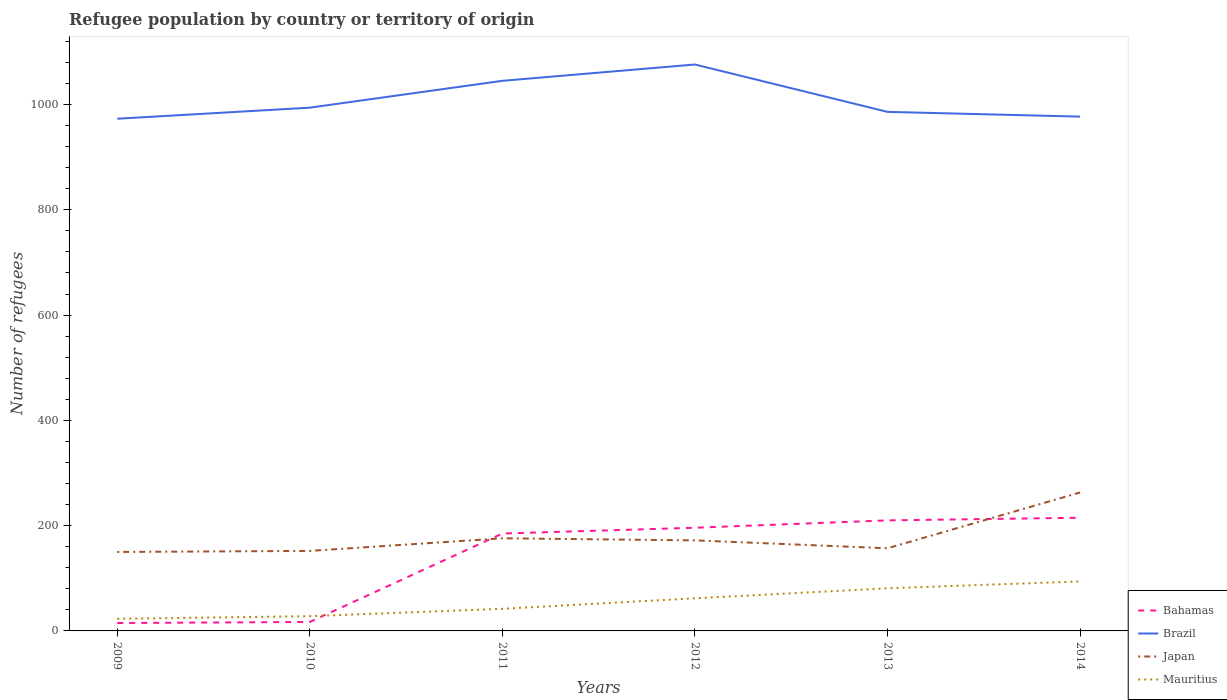Is the number of lines equal to the number of legend labels?
Offer a terse response. Yes. What is the difference between the highest and the second highest number of refugees in Japan?
Provide a succinct answer. 113. What is the difference between the highest and the lowest number of refugees in Japan?
Your response must be concise. 1. How many lines are there?
Provide a short and direct response. 4. How many years are there in the graph?
Your response must be concise. 6. Does the graph contain any zero values?
Make the answer very short. No. What is the title of the graph?
Keep it short and to the point. Refugee population by country or territory of origin. What is the label or title of the X-axis?
Your answer should be compact. Years. What is the label or title of the Y-axis?
Provide a succinct answer. Number of refugees. What is the Number of refugees of Bahamas in 2009?
Keep it short and to the point. 15. What is the Number of refugees in Brazil in 2009?
Your answer should be compact. 973. What is the Number of refugees of Japan in 2009?
Your response must be concise. 150. What is the Number of refugees in Mauritius in 2009?
Make the answer very short. 23. What is the Number of refugees in Bahamas in 2010?
Your answer should be compact. 17. What is the Number of refugees of Brazil in 2010?
Provide a succinct answer. 994. What is the Number of refugees in Japan in 2010?
Offer a very short reply. 152. What is the Number of refugees of Bahamas in 2011?
Your answer should be compact. 185. What is the Number of refugees in Brazil in 2011?
Give a very brief answer. 1045. What is the Number of refugees in Japan in 2011?
Your response must be concise. 176. What is the Number of refugees of Bahamas in 2012?
Give a very brief answer. 196. What is the Number of refugees of Brazil in 2012?
Your answer should be compact. 1076. What is the Number of refugees in Japan in 2012?
Ensure brevity in your answer.  172. What is the Number of refugees in Bahamas in 2013?
Offer a terse response. 210. What is the Number of refugees of Brazil in 2013?
Provide a short and direct response. 986. What is the Number of refugees in Japan in 2013?
Your answer should be very brief. 157. What is the Number of refugees in Mauritius in 2013?
Your response must be concise. 81. What is the Number of refugees of Bahamas in 2014?
Provide a short and direct response. 215. What is the Number of refugees of Brazil in 2014?
Provide a succinct answer. 977. What is the Number of refugees in Japan in 2014?
Ensure brevity in your answer.  263. What is the Number of refugees in Mauritius in 2014?
Provide a short and direct response. 94. Across all years, what is the maximum Number of refugees of Bahamas?
Keep it short and to the point. 215. Across all years, what is the maximum Number of refugees in Brazil?
Keep it short and to the point. 1076. Across all years, what is the maximum Number of refugees of Japan?
Your response must be concise. 263. Across all years, what is the maximum Number of refugees in Mauritius?
Provide a short and direct response. 94. Across all years, what is the minimum Number of refugees of Brazil?
Your answer should be compact. 973. Across all years, what is the minimum Number of refugees in Japan?
Provide a short and direct response. 150. Across all years, what is the minimum Number of refugees of Mauritius?
Keep it short and to the point. 23. What is the total Number of refugees of Bahamas in the graph?
Provide a succinct answer. 838. What is the total Number of refugees of Brazil in the graph?
Your answer should be compact. 6051. What is the total Number of refugees in Japan in the graph?
Ensure brevity in your answer.  1070. What is the total Number of refugees in Mauritius in the graph?
Provide a short and direct response. 330. What is the difference between the Number of refugees of Brazil in 2009 and that in 2010?
Offer a terse response. -21. What is the difference between the Number of refugees of Mauritius in 2009 and that in 2010?
Make the answer very short. -5. What is the difference between the Number of refugees of Bahamas in 2009 and that in 2011?
Provide a succinct answer. -170. What is the difference between the Number of refugees in Brazil in 2009 and that in 2011?
Your answer should be very brief. -72. What is the difference between the Number of refugees in Bahamas in 2009 and that in 2012?
Your response must be concise. -181. What is the difference between the Number of refugees of Brazil in 2009 and that in 2012?
Your response must be concise. -103. What is the difference between the Number of refugees of Japan in 2009 and that in 2012?
Your answer should be very brief. -22. What is the difference between the Number of refugees in Mauritius in 2009 and that in 2012?
Provide a succinct answer. -39. What is the difference between the Number of refugees in Bahamas in 2009 and that in 2013?
Offer a terse response. -195. What is the difference between the Number of refugees of Brazil in 2009 and that in 2013?
Offer a terse response. -13. What is the difference between the Number of refugees of Japan in 2009 and that in 2013?
Offer a terse response. -7. What is the difference between the Number of refugees of Mauritius in 2009 and that in 2013?
Provide a succinct answer. -58. What is the difference between the Number of refugees of Bahamas in 2009 and that in 2014?
Offer a very short reply. -200. What is the difference between the Number of refugees of Brazil in 2009 and that in 2014?
Provide a short and direct response. -4. What is the difference between the Number of refugees of Japan in 2009 and that in 2014?
Make the answer very short. -113. What is the difference between the Number of refugees in Mauritius in 2009 and that in 2014?
Ensure brevity in your answer.  -71. What is the difference between the Number of refugees in Bahamas in 2010 and that in 2011?
Make the answer very short. -168. What is the difference between the Number of refugees of Brazil in 2010 and that in 2011?
Offer a very short reply. -51. What is the difference between the Number of refugees of Bahamas in 2010 and that in 2012?
Your response must be concise. -179. What is the difference between the Number of refugees of Brazil in 2010 and that in 2012?
Your answer should be very brief. -82. What is the difference between the Number of refugees of Japan in 2010 and that in 2012?
Provide a succinct answer. -20. What is the difference between the Number of refugees in Mauritius in 2010 and that in 2012?
Give a very brief answer. -34. What is the difference between the Number of refugees in Bahamas in 2010 and that in 2013?
Your response must be concise. -193. What is the difference between the Number of refugees in Mauritius in 2010 and that in 2013?
Make the answer very short. -53. What is the difference between the Number of refugees in Bahamas in 2010 and that in 2014?
Offer a terse response. -198. What is the difference between the Number of refugees of Brazil in 2010 and that in 2014?
Provide a succinct answer. 17. What is the difference between the Number of refugees in Japan in 2010 and that in 2014?
Offer a terse response. -111. What is the difference between the Number of refugees of Mauritius in 2010 and that in 2014?
Offer a terse response. -66. What is the difference between the Number of refugees of Bahamas in 2011 and that in 2012?
Ensure brevity in your answer.  -11. What is the difference between the Number of refugees of Brazil in 2011 and that in 2012?
Ensure brevity in your answer.  -31. What is the difference between the Number of refugees of Brazil in 2011 and that in 2013?
Provide a short and direct response. 59. What is the difference between the Number of refugees in Japan in 2011 and that in 2013?
Your answer should be compact. 19. What is the difference between the Number of refugees in Mauritius in 2011 and that in 2013?
Keep it short and to the point. -39. What is the difference between the Number of refugees of Bahamas in 2011 and that in 2014?
Your answer should be compact. -30. What is the difference between the Number of refugees of Japan in 2011 and that in 2014?
Keep it short and to the point. -87. What is the difference between the Number of refugees in Mauritius in 2011 and that in 2014?
Offer a terse response. -52. What is the difference between the Number of refugees in Japan in 2012 and that in 2013?
Provide a short and direct response. 15. What is the difference between the Number of refugees in Mauritius in 2012 and that in 2013?
Your response must be concise. -19. What is the difference between the Number of refugees of Brazil in 2012 and that in 2014?
Offer a very short reply. 99. What is the difference between the Number of refugees in Japan in 2012 and that in 2014?
Offer a very short reply. -91. What is the difference between the Number of refugees in Mauritius in 2012 and that in 2014?
Provide a short and direct response. -32. What is the difference between the Number of refugees in Bahamas in 2013 and that in 2014?
Ensure brevity in your answer.  -5. What is the difference between the Number of refugees in Brazil in 2013 and that in 2014?
Keep it short and to the point. 9. What is the difference between the Number of refugees in Japan in 2013 and that in 2014?
Make the answer very short. -106. What is the difference between the Number of refugees in Bahamas in 2009 and the Number of refugees in Brazil in 2010?
Your answer should be very brief. -979. What is the difference between the Number of refugees in Bahamas in 2009 and the Number of refugees in Japan in 2010?
Provide a succinct answer. -137. What is the difference between the Number of refugees of Bahamas in 2009 and the Number of refugees of Mauritius in 2010?
Offer a terse response. -13. What is the difference between the Number of refugees of Brazil in 2009 and the Number of refugees of Japan in 2010?
Your response must be concise. 821. What is the difference between the Number of refugees in Brazil in 2009 and the Number of refugees in Mauritius in 2010?
Ensure brevity in your answer.  945. What is the difference between the Number of refugees of Japan in 2009 and the Number of refugees of Mauritius in 2010?
Your response must be concise. 122. What is the difference between the Number of refugees in Bahamas in 2009 and the Number of refugees in Brazil in 2011?
Offer a terse response. -1030. What is the difference between the Number of refugees of Bahamas in 2009 and the Number of refugees of Japan in 2011?
Provide a succinct answer. -161. What is the difference between the Number of refugees of Bahamas in 2009 and the Number of refugees of Mauritius in 2011?
Your response must be concise. -27. What is the difference between the Number of refugees of Brazil in 2009 and the Number of refugees of Japan in 2011?
Offer a very short reply. 797. What is the difference between the Number of refugees in Brazil in 2009 and the Number of refugees in Mauritius in 2011?
Make the answer very short. 931. What is the difference between the Number of refugees of Japan in 2009 and the Number of refugees of Mauritius in 2011?
Provide a succinct answer. 108. What is the difference between the Number of refugees of Bahamas in 2009 and the Number of refugees of Brazil in 2012?
Your response must be concise. -1061. What is the difference between the Number of refugees in Bahamas in 2009 and the Number of refugees in Japan in 2012?
Offer a terse response. -157. What is the difference between the Number of refugees of Bahamas in 2009 and the Number of refugees of Mauritius in 2012?
Ensure brevity in your answer.  -47. What is the difference between the Number of refugees in Brazil in 2009 and the Number of refugees in Japan in 2012?
Ensure brevity in your answer.  801. What is the difference between the Number of refugees of Brazil in 2009 and the Number of refugees of Mauritius in 2012?
Offer a terse response. 911. What is the difference between the Number of refugees of Bahamas in 2009 and the Number of refugees of Brazil in 2013?
Your answer should be very brief. -971. What is the difference between the Number of refugees of Bahamas in 2009 and the Number of refugees of Japan in 2013?
Your response must be concise. -142. What is the difference between the Number of refugees in Bahamas in 2009 and the Number of refugees in Mauritius in 2013?
Your answer should be very brief. -66. What is the difference between the Number of refugees of Brazil in 2009 and the Number of refugees of Japan in 2013?
Offer a terse response. 816. What is the difference between the Number of refugees of Brazil in 2009 and the Number of refugees of Mauritius in 2013?
Offer a terse response. 892. What is the difference between the Number of refugees of Bahamas in 2009 and the Number of refugees of Brazil in 2014?
Your answer should be very brief. -962. What is the difference between the Number of refugees in Bahamas in 2009 and the Number of refugees in Japan in 2014?
Ensure brevity in your answer.  -248. What is the difference between the Number of refugees of Bahamas in 2009 and the Number of refugees of Mauritius in 2014?
Your answer should be compact. -79. What is the difference between the Number of refugees in Brazil in 2009 and the Number of refugees in Japan in 2014?
Your response must be concise. 710. What is the difference between the Number of refugees in Brazil in 2009 and the Number of refugees in Mauritius in 2014?
Your answer should be compact. 879. What is the difference between the Number of refugees in Bahamas in 2010 and the Number of refugees in Brazil in 2011?
Provide a succinct answer. -1028. What is the difference between the Number of refugees in Bahamas in 2010 and the Number of refugees in Japan in 2011?
Give a very brief answer. -159. What is the difference between the Number of refugees in Brazil in 2010 and the Number of refugees in Japan in 2011?
Make the answer very short. 818. What is the difference between the Number of refugees in Brazil in 2010 and the Number of refugees in Mauritius in 2011?
Give a very brief answer. 952. What is the difference between the Number of refugees of Japan in 2010 and the Number of refugees of Mauritius in 2011?
Provide a succinct answer. 110. What is the difference between the Number of refugees in Bahamas in 2010 and the Number of refugees in Brazil in 2012?
Make the answer very short. -1059. What is the difference between the Number of refugees in Bahamas in 2010 and the Number of refugees in Japan in 2012?
Keep it short and to the point. -155. What is the difference between the Number of refugees in Bahamas in 2010 and the Number of refugees in Mauritius in 2012?
Give a very brief answer. -45. What is the difference between the Number of refugees in Brazil in 2010 and the Number of refugees in Japan in 2012?
Your answer should be compact. 822. What is the difference between the Number of refugees of Brazil in 2010 and the Number of refugees of Mauritius in 2012?
Provide a short and direct response. 932. What is the difference between the Number of refugees in Japan in 2010 and the Number of refugees in Mauritius in 2012?
Your response must be concise. 90. What is the difference between the Number of refugees in Bahamas in 2010 and the Number of refugees in Brazil in 2013?
Your response must be concise. -969. What is the difference between the Number of refugees of Bahamas in 2010 and the Number of refugees of Japan in 2013?
Your answer should be compact. -140. What is the difference between the Number of refugees in Bahamas in 2010 and the Number of refugees in Mauritius in 2013?
Provide a succinct answer. -64. What is the difference between the Number of refugees of Brazil in 2010 and the Number of refugees of Japan in 2013?
Offer a terse response. 837. What is the difference between the Number of refugees in Brazil in 2010 and the Number of refugees in Mauritius in 2013?
Provide a short and direct response. 913. What is the difference between the Number of refugees in Japan in 2010 and the Number of refugees in Mauritius in 2013?
Offer a terse response. 71. What is the difference between the Number of refugees of Bahamas in 2010 and the Number of refugees of Brazil in 2014?
Ensure brevity in your answer.  -960. What is the difference between the Number of refugees of Bahamas in 2010 and the Number of refugees of Japan in 2014?
Your answer should be very brief. -246. What is the difference between the Number of refugees of Bahamas in 2010 and the Number of refugees of Mauritius in 2014?
Offer a very short reply. -77. What is the difference between the Number of refugees in Brazil in 2010 and the Number of refugees in Japan in 2014?
Offer a very short reply. 731. What is the difference between the Number of refugees in Brazil in 2010 and the Number of refugees in Mauritius in 2014?
Offer a terse response. 900. What is the difference between the Number of refugees of Bahamas in 2011 and the Number of refugees of Brazil in 2012?
Provide a succinct answer. -891. What is the difference between the Number of refugees of Bahamas in 2011 and the Number of refugees of Japan in 2012?
Provide a short and direct response. 13. What is the difference between the Number of refugees of Bahamas in 2011 and the Number of refugees of Mauritius in 2012?
Make the answer very short. 123. What is the difference between the Number of refugees of Brazil in 2011 and the Number of refugees of Japan in 2012?
Provide a short and direct response. 873. What is the difference between the Number of refugees in Brazil in 2011 and the Number of refugees in Mauritius in 2012?
Make the answer very short. 983. What is the difference between the Number of refugees in Japan in 2011 and the Number of refugees in Mauritius in 2012?
Offer a very short reply. 114. What is the difference between the Number of refugees in Bahamas in 2011 and the Number of refugees in Brazil in 2013?
Provide a succinct answer. -801. What is the difference between the Number of refugees in Bahamas in 2011 and the Number of refugees in Mauritius in 2013?
Your answer should be very brief. 104. What is the difference between the Number of refugees in Brazil in 2011 and the Number of refugees in Japan in 2013?
Provide a succinct answer. 888. What is the difference between the Number of refugees in Brazil in 2011 and the Number of refugees in Mauritius in 2013?
Offer a terse response. 964. What is the difference between the Number of refugees in Japan in 2011 and the Number of refugees in Mauritius in 2013?
Your answer should be compact. 95. What is the difference between the Number of refugees of Bahamas in 2011 and the Number of refugees of Brazil in 2014?
Make the answer very short. -792. What is the difference between the Number of refugees of Bahamas in 2011 and the Number of refugees of Japan in 2014?
Provide a short and direct response. -78. What is the difference between the Number of refugees in Bahamas in 2011 and the Number of refugees in Mauritius in 2014?
Your answer should be compact. 91. What is the difference between the Number of refugees of Brazil in 2011 and the Number of refugees of Japan in 2014?
Provide a succinct answer. 782. What is the difference between the Number of refugees in Brazil in 2011 and the Number of refugees in Mauritius in 2014?
Keep it short and to the point. 951. What is the difference between the Number of refugees of Japan in 2011 and the Number of refugees of Mauritius in 2014?
Provide a short and direct response. 82. What is the difference between the Number of refugees in Bahamas in 2012 and the Number of refugees in Brazil in 2013?
Offer a terse response. -790. What is the difference between the Number of refugees of Bahamas in 2012 and the Number of refugees of Japan in 2013?
Your response must be concise. 39. What is the difference between the Number of refugees in Bahamas in 2012 and the Number of refugees in Mauritius in 2013?
Provide a short and direct response. 115. What is the difference between the Number of refugees in Brazil in 2012 and the Number of refugees in Japan in 2013?
Provide a short and direct response. 919. What is the difference between the Number of refugees in Brazil in 2012 and the Number of refugees in Mauritius in 2013?
Offer a terse response. 995. What is the difference between the Number of refugees in Japan in 2012 and the Number of refugees in Mauritius in 2013?
Make the answer very short. 91. What is the difference between the Number of refugees of Bahamas in 2012 and the Number of refugees of Brazil in 2014?
Make the answer very short. -781. What is the difference between the Number of refugees in Bahamas in 2012 and the Number of refugees in Japan in 2014?
Ensure brevity in your answer.  -67. What is the difference between the Number of refugees of Bahamas in 2012 and the Number of refugees of Mauritius in 2014?
Offer a terse response. 102. What is the difference between the Number of refugees in Brazil in 2012 and the Number of refugees in Japan in 2014?
Make the answer very short. 813. What is the difference between the Number of refugees in Brazil in 2012 and the Number of refugees in Mauritius in 2014?
Your response must be concise. 982. What is the difference between the Number of refugees in Bahamas in 2013 and the Number of refugees in Brazil in 2014?
Your answer should be compact. -767. What is the difference between the Number of refugees in Bahamas in 2013 and the Number of refugees in Japan in 2014?
Offer a very short reply. -53. What is the difference between the Number of refugees in Bahamas in 2013 and the Number of refugees in Mauritius in 2014?
Your answer should be very brief. 116. What is the difference between the Number of refugees of Brazil in 2013 and the Number of refugees of Japan in 2014?
Your response must be concise. 723. What is the difference between the Number of refugees in Brazil in 2013 and the Number of refugees in Mauritius in 2014?
Your answer should be very brief. 892. What is the difference between the Number of refugees of Japan in 2013 and the Number of refugees of Mauritius in 2014?
Offer a very short reply. 63. What is the average Number of refugees of Bahamas per year?
Make the answer very short. 139.67. What is the average Number of refugees in Brazil per year?
Your response must be concise. 1008.5. What is the average Number of refugees in Japan per year?
Keep it short and to the point. 178.33. What is the average Number of refugees in Mauritius per year?
Provide a short and direct response. 55. In the year 2009, what is the difference between the Number of refugees in Bahamas and Number of refugees in Brazil?
Your answer should be very brief. -958. In the year 2009, what is the difference between the Number of refugees of Bahamas and Number of refugees of Japan?
Keep it short and to the point. -135. In the year 2009, what is the difference between the Number of refugees of Bahamas and Number of refugees of Mauritius?
Offer a very short reply. -8. In the year 2009, what is the difference between the Number of refugees of Brazil and Number of refugees of Japan?
Your answer should be very brief. 823. In the year 2009, what is the difference between the Number of refugees of Brazil and Number of refugees of Mauritius?
Your answer should be very brief. 950. In the year 2009, what is the difference between the Number of refugees in Japan and Number of refugees in Mauritius?
Your answer should be very brief. 127. In the year 2010, what is the difference between the Number of refugees of Bahamas and Number of refugees of Brazil?
Your answer should be very brief. -977. In the year 2010, what is the difference between the Number of refugees in Bahamas and Number of refugees in Japan?
Ensure brevity in your answer.  -135. In the year 2010, what is the difference between the Number of refugees in Brazil and Number of refugees in Japan?
Keep it short and to the point. 842. In the year 2010, what is the difference between the Number of refugees in Brazil and Number of refugees in Mauritius?
Offer a terse response. 966. In the year 2010, what is the difference between the Number of refugees in Japan and Number of refugees in Mauritius?
Your response must be concise. 124. In the year 2011, what is the difference between the Number of refugees of Bahamas and Number of refugees of Brazil?
Give a very brief answer. -860. In the year 2011, what is the difference between the Number of refugees in Bahamas and Number of refugees in Mauritius?
Provide a succinct answer. 143. In the year 2011, what is the difference between the Number of refugees in Brazil and Number of refugees in Japan?
Your response must be concise. 869. In the year 2011, what is the difference between the Number of refugees in Brazil and Number of refugees in Mauritius?
Give a very brief answer. 1003. In the year 2011, what is the difference between the Number of refugees of Japan and Number of refugees of Mauritius?
Give a very brief answer. 134. In the year 2012, what is the difference between the Number of refugees of Bahamas and Number of refugees of Brazil?
Offer a terse response. -880. In the year 2012, what is the difference between the Number of refugees in Bahamas and Number of refugees in Mauritius?
Your response must be concise. 134. In the year 2012, what is the difference between the Number of refugees in Brazil and Number of refugees in Japan?
Your answer should be very brief. 904. In the year 2012, what is the difference between the Number of refugees in Brazil and Number of refugees in Mauritius?
Provide a succinct answer. 1014. In the year 2012, what is the difference between the Number of refugees in Japan and Number of refugees in Mauritius?
Ensure brevity in your answer.  110. In the year 2013, what is the difference between the Number of refugees of Bahamas and Number of refugees of Brazil?
Provide a short and direct response. -776. In the year 2013, what is the difference between the Number of refugees of Bahamas and Number of refugees of Mauritius?
Make the answer very short. 129. In the year 2013, what is the difference between the Number of refugees in Brazil and Number of refugees in Japan?
Your answer should be compact. 829. In the year 2013, what is the difference between the Number of refugees of Brazil and Number of refugees of Mauritius?
Make the answer very short. 905. In the year 2013, what is the difference between the Number of refugees in Japan and Number of refugees in Mauritius?
Offer a very short reply. 76. In the year 2014, what is the difference between the Number of refugees of Bahamas and Number of refugees of Brazil?
Offer a terse response. -762. In the year 2014, what is the difference between the Number of refugees of Bahamas and Number of refugees of Japan?
Your response must be concise. -48. In the year 2014, what is the difference between the Number of refugees in Bahamas and Number of refugees in Mauritius?
Make the answer very short. 121. In the year 2014, what is the difference between the Number of refugees in Brazil and Number of refugees in Japan?
Provide a succinct answer. 714. In the year 2014, what is the difference between the Number of refugees of Brazil and Number of refugees of Mauritius?
Your answer should be very brief. 883. In the year 2014, what is the difference between the Number of refugees of Japan and Number of refugees of Mauritius?
Your answer should be very brief. 169. What is the ratio of the Number of refugees in Bahamas in 2009 to that in 2010?
Give a very brief answer. 0.88. What is the ratio of the Number of refugees in Brazil in 2009 to that in 2010?
Your response must be concise. 0.98. What is the ratio of the Number of refugees in Japan in 2009 to that in 2010?
Make the answer very short. 0.99. What is the ratio of the Number of refugees in Mauritius in 2009 to that in 2010?
Offer a terse response. 0.82. What is the ratio of the Number of refugees of Bahamas in 2009 to that in 2011?
Ensure brevity in your answer.  0.08. What is the ratio of the Number of refugees of Brazil in 2009 to that in 2011?
Make the answer very short. 0.93. What is the ratio of the Number of refugees in Japan in 2009 to that in 2011?
Ensure brevity in your answer.  0.85. What is the ratio of the Number of refugees in Mauritius in 2009 to that in 2011?
Your answer should be compact. 0.55. What is the ratio of the Number of refugees of Bahamas in 2009 to that in 2012?
Provide a short and direct response. 0.08. What is the ratio of the Number of refugees of Brazil in 2009 to that in 2012?
Your answer should be compact. 0.9. What is the ratio of the Number of refugees in Japan in 2009 to that in 2012?
Offer a very short reply. 0.87. What is the ratio of the Number of refugees in Mauritius in 2009 to that in 2012?
Offer a very short reply. 0.37. What is the ratio of the Number of refugees in Bahamas in 2009 to that in 2013?
Offer a very short reply. 0.07. What is the ratio of the Number of refugees in Brazil in 2009 to that in 2013?
Give a very brief answer. 0.99. What is the ratio of the Number of refugees of Japan in 2009 to that in 2013?
Provide a short and direct response. 0.96. What is the ratio of the Number of refugees in Mauritius in 2009 to that in 2013?
Make the answer very short. 0.28. What is the ratio of the Number of refugees of Bahamas in 2009 to that in 2014?
Keep it short and to the point. 0.07. What is the ratio of the Number of refugees of Japan in 2009 to that in 2014?
Give a very brief answer. 0.57. What is the ratio of the Number of refugees in Mauritius in 2009 to that in 2014?
Your answer should be compact. 0.24. What is the ratio of the Number of refugees of Bahamas in 2010 to that in 2011?
Make the answer very short. 0.09. What is the ratio of the Number of refugees of Brazil in 2010 to that in 2011?
Your answer should be very brief. 0.95. What is the ratio of the Number of refugees of Japan in 2010 to that in 2011?
Keep it short and to the point. 0.86. What is the ratio of the Number of refugees of Mauritius in 2010 to that in 2011?
Your response must be concise. 0.67. What is the ratio of the Number of refugees in Bahamas in 2010 to that in 2012?
Keep it short and to the point. 0.09. What is the ratio of the Number of refugees of Brazil in 2010 to that in 2012?
Your answer should be very brief. 0.92. What is the ratio of the Number of refugees in Japan in 2010 to that in 2012?
Keep it short and to the point. 0.88. What is the ratio of the Number of refugees in Mauritius in 2010 to that in 2012?
Provide a short and direct response. 0.45. What is the ratio of the Number of refugees of Bahamas in 2010 to that in 2013?
Your answer should be very brief. 0.08. What is the ratio of the Number of refugees in Brazil in 2010 to that in 2013?
Give a very brief answer. 1.01. What is the ratio of the Number of refugees of Japan in 2010 to that in 2013?
Ensure brevity in your answer.  0.97. What is the ratio of the Number of refugees in Mauritius in 2010 to that in 2013?
Your response must be concise. 0.35. What is the ratio of the Number of refugees in Bahamas in 2010 to that in 2014?
Give a very brief answer. 0.08. What is the ratio of the Number of refugees in Brazil in 2010 to that in 2014?
Provide a succinct answer. 1.02. What is the ratio of the Number of refugees in Japan in 2010 to that in 2014?
Your answer should be compact. 0.58. What is the ratio of the Number of refugees of Mauritius in 2010 to that in 2014?
Give a very brief answer. 0.3. What is the ratio of the Number of refugees in Bahamas in 2011 to that in 2012?
Give a very brief answer. 0.94. What is the ratio of the Number of refugees of Brazil in 2011 to that in 2012?
Keep it short and to the point. 0.97. What is the ratio of the Number of refugees in Japan in 2011 to that in 2012?
Make the answer very short. 1.02. What is the ratio of the Number of refugees of Mauritius in 2011 to that in 2012?
Provide a short and direct response. 0.68. What is the ratio of the Number of refugees in Bahamas in 2011 to that in 2013?
Provide a short and direct response. 0.88. What is the ratio of the Number of refugees of Brazil in 2011 to that in 2013?
Provide a succinct answer. 1.06. What is the ratio of the Number of refugees of Japan in 2011 to that in 2013?
Offer a very short reply. 1.12. What is the ratio of the Number of refugees in Mauritius in 2011 to that in 2013?
Your response must be concise. 0.52. What is the ratio of the Number of refugees of Bahamas in 2011 to that in 2014?
Ensure brevity in your answer.  0.86. What is the ratio of the Number of refugees of Brazil in 2011 to that in 2014?
Make the answer very short. 1.07. What is the ratio of the Number of refugees of Japan in 2011 to that in 2014?
Make the answer very short. 0.67. What is the ratio of the Number of refugees in Mauritius in 2011 to that in 2014?
Give a very brief answer. 0.45. What is the ratio of the Number of refugees in Brazil in 2012 to that in 2013?
Provide a short and direct response. 1.09. What is the ratio of the Number of refugees in Japan in 2012 to that in 2013?
Your answer should be compact. 1.1. What is the ratio of the Number of refugees in Mauritius in 2012 to that in 2013?
Your answer should be compact. 0.77. What is the ratio of the Number of refugees in Bahamas in 2012 to that in 2014?
Your response must be concise. 0.91. What is the ratio of the Number of refugees in Brazil in 2012 to that in 2014?
Make the answer very short. 1.1. What is the ratio of the Number of refugees in Japan in 2012 to that in 2014?
Offer a very short reply. 0.65. What is the ratio of the Number of refugees in Mauritius in 2012 to that in 2014?
Ensure brevity in your answer.  0.66. What is the ratio of the Number of refugees of Bahamas in 2013 to that in 2014?
Provide a succinct answer. 0.98. What is the ratio of the Number of refugees of Brazil in 2013 to that in 2014?
Your answer should be very brief. 1.01. What is the ratio of the Number of refugees of Japan in 2013 to that in 2014?
Offer a terse response. 0.6. What is the ratio of the Number of refugees of Mauritius in 2013 to that in 2014?
Your response must be concise. 0.86. What is the difference between the highest and the second highest Number of refugees in Mauritius?
Your answer should be very brief. 13. What is the difference between the highest and the lowest Number of refugees in Brazil?
Offer a terse response. 103. What is the difference between the highest and the lowest Number of refugees of Japan?
Make the answer very short. 113. What is the difference between the highest and the lowest Number of refugees in Mauritius?
Your response must be concise. 71. 